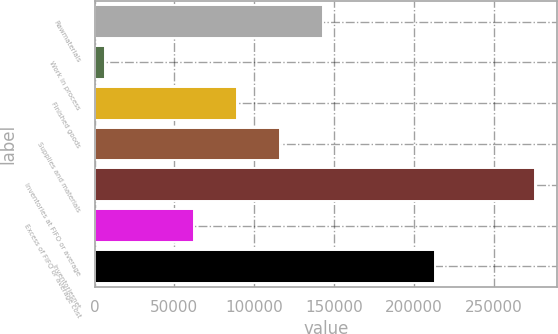<chart> <loc_0><loc_0><loc_500><loc_500><bar_chart><fcel>Rawmaterials<fcel>Work in process<fcel>Finished goods<fcel>Supplies and materials<fcel>Inventories at FIFO or average<fcel>Excess of FIFO or average cost<fcel>Inventoriesnet<nl><fcel>143349<fcel>6600<fcel>89480.2<fcel>116414<fcel>275942<fcel>62546<fcel>213396<nl></chart> 